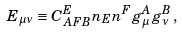Convert formula to latex. <formula><loc_0><loc_0><loc_500><loc_500>E _ { \mu \nu } \equiv C _ { A F B } ^ { E } n _ { E } n ^ { F } g _ { \mu } ^ { A } g _ { \nu } ^ { B } \, ,</formula> 